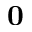<formula> <loc_0><loc_0><loc_500><loc_500>0</formula> 